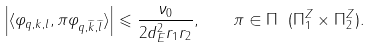Convert formula to latex. <formula><loc_0><loc_0><loc_500><loc_500>\left | \langle \varphi _ { q , k , l } , \pi \varphi _ { q , \widetilde { k } , \widetilde { l } } \rangle \right | \leqslant \frac { \nu _ { 0 } } { 2 d _ { E } ^ { 2 } r _ { 1 } r _ { 2 } } , \quad \pi \in \Pi \ ( \Pi ^ { Z } _ { 1 } \times \Pi ^ { Z } _ { 2 } ) .</formula> 